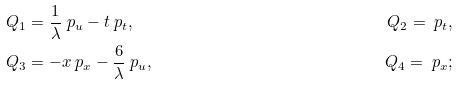<formula> <loc_0><loc_0><loc_500><loc_500>& Q _ { 1 } = \frac { 1 } { \lambda } \ p _ { u } - t \ p _ { t } , & Q _ { 2 } = \ p _ { t } , \\ & Q _ { 3 } = - x \ p _ { x } - \frac { 6 } { \lambda } \ p _ { u } , & Q _ { 4 } = \ p _ { x } ;</formula> 